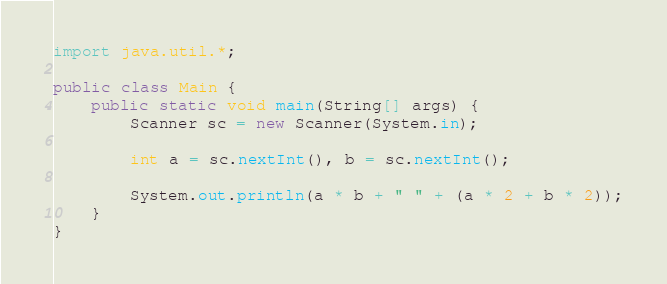Convert code to text. <code><loc_0><loc_0><loc_500><loc_500><_Java_>import java.util.*;

public class Main {
	public static void main(String[] args) {
		Scanner sc = new Scanner(System.in);
		
		int a = sc.nextInt(), b = sc.nextInt();
		
		System.out.println(a * b + " " + (a * 2 + b * 2));
	}
}</code> 